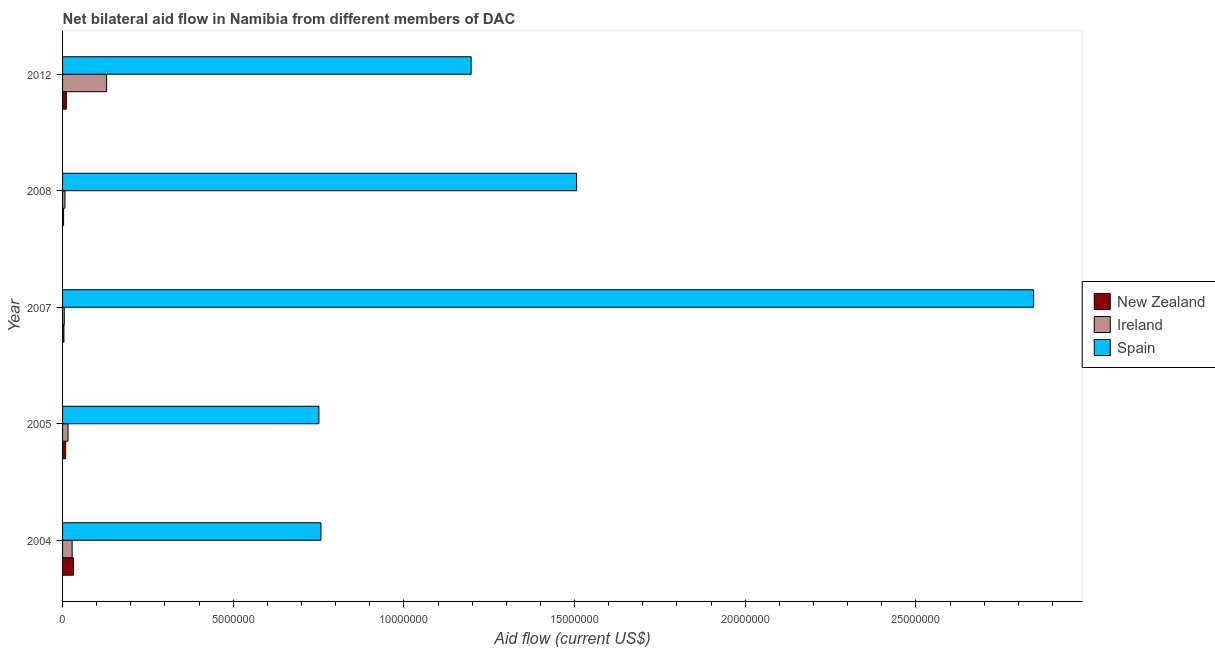How many groups of bars are there?
Provide a short and direct response. 5. Are the number of bars per tick equal to the number of legend labels?
Provide a short and direct response. Yes. Are the number of bars on each tick of the Y-axis equal?
Your answer should be compact. Yes. How many bars are there on the 5th tick from the top?
Your answer should be very brief. 3. How many bars are there on the 3rd tick from the bottom?
Provide a succinct answer. 3. In how many cases, is the number of bars for a given year not equal to the number of legend labels?
Offer a very short reply. 0. What is the amount of aid provided by spain in 2012?
Offer a terse response. 1.20e+07. Across all years, what is the maximum amount of aid provided by new zealand?
Your answer should be compact. 3.20e+05. Across all years, what is the minimum amount of aid provided by spain?
Give a very brief answer. 7.51e+06. In which year was the amount of aid provided by new zealand maximum?
Offer a very short reply. 2004. What is the total amount of aid provided by ireland in the graph?
Your answer should be compact. 1.85e+06. What is the difference between the amount of aid provided by new zealand in 2004 and that in 2008?
Provide a succinct answer. 2.90e+05. What is the difference between the amount of aid provided by spain in 2007 and the amount of aid provided by new zealand in 2008?
Provide a short and direct response. 2.84e+07. What is the average amount of aid provided by new zealand per year?
Offer a very short reply. 1.18e+05. In the year 2008, what is the difference between the amount of aid provided by spain and amount of aid provided by ireland?
Offer a terse response. 1.50e+07. What is the ratio of the amount of aid provided by ireland in 2007 to that in 2008?
Your response must be concise. 0.71. What is the difference between the highest and the second highest amount of aid provided by spain?
Your answer should be compact. 1.34e+07. What is the difference between the highest and the lowest amount of aid provided by new zealand?
Give a very brief answer. 2.90e+05. Is the sum of the amount of aid provided by spain in 2005 and 2007 greater than the maximum amount of aid provided by ireland across all years?
Your response must be concise. Yes. What does the 1st bar from the top in 2008 represents?
Ensure brevity in your answer.  Spain. What does the 2nd bar from the bottom in 2008 represents?
Keep it short and to the point. Ireland. How many bars are there?
Your answer should be compact. 15. Are all the bars in the graph horizontal?
Offer a terse response. Yes. Does the graph contain grids?
Offer a terse response. No. Where does the legend appear in the graph?
Your response must be concise. Center right. What is the title of the graph?
Ensure brevity in your answer.  Net bilateral aid flow in Namibia from different members of DAC. What is the label or title of the Y-axis?
Your answer should be very brief. Year. What is the Aid flow (current US$) of Ireland in 2004?
Your answer should be compact. 2.80e+05. What is the Aid flow (current US$) in Spain in 2004?
Your answer should be compact. 7.57e+06. What is the Aid flow (current US$) in New Zealand in 2005?
Offer a very short reply. 9.00e+04. What is the Aid flow (current US$) in Spain in 2005?
Make the answer very short. 7.51e+06. What is the Aid flow (current US$) in Ireland in 2007?
Give a very brief answer. 5.00e+04. What is the Aid flow (current US$) of Spain in 2007?
Your answer should be compact. 2.84e+07. What is the Aid flow (current US$) of New Zealand in 2008?
Ensure brevity in your answer.  3.00e+04. What is the Aid flow (current US$) in Ireland in 2008?
Provide a succinct answer. 7.00e+04. What is the Aid flow (current US$) in Spain in 2008?
Provide a short and direct response. 1.51e+07. What is the Aid flow (current US$) of Ireland in 2012?
Your answer should be compact. 1.29e+06. What is the Aid flow (current US$) of Spain in 2012?
Give a very brief answer. 1.20e+07. Across all years, what is the maximum Aid flow (current US$) of New Zealand?
Provide a succinct answer. 3.20e+05. Across all years, what is the maximum Aid flow (current US$) in Ireland?
Your answer should be compact. 1.29e+06. Across all years, what is the maximum Aid flow (current US$) of Spain?
Give a very brief answer. 2.84e+07. Across all years, what is the minimum Aid flow (current US$) of New Zealand?
Offer a terse response. 3.00e+04. Across all years, what is the minimum Aid flow (current US$) in Ireland?
Ensure brevity in your answer.  5.00e+04. Across all years, what is the minimum Aid flow (current US$) in Spain?
Your response must be concise. 7.51e+06. What is the total Aid flow (current US$) in New Zealand in the graph?
Offer a terse response. 5.90e+05. What is the total Aid flow (current US$) of Ireland in the graph?
Give a very brief answer. 1.85e+06. What is the total Aid flow (current US$) in Spain in the graph?
Provide a succinct answer. 7.06e+07. What is the difference between the Aid flow (current US$) of New Zealand in 2004 and that in 2005?
Offer a terse response. 2.30e+05. What is the difference between the Aid flow (current US$) in New Zealand in 2004 and that in 2007?
Offer a terse response. 2.80e+05. What is the difference between the Aid flow (current US$) of Ireland in 2004 and that in 2007?
Your response must be concise. 2.30e+05. What is the difference between the Aid flow (current US$) of Spain in 2004 and that in 2007?
Keep it short and to the point. -2.09e+07. What is the difference between the Aid flow (current US$) of Ireland in 2004 and that in 2008?
Offer a very short reply. 2.10e+05. What is the difference between the Aid flow (current US$) of Spain in 2004 and that in 2008?
Ensure brevity in your answer.  -7.49e+06. What is the difference between the Aid flow (current US$) of Ireland in 2004 and that in 2012?
Your response must be concise. -1.01e+06. What is the difference between the Aid flow (current US$) of Spain in 2004 and that in 2012?
Offer a terse response. -4.40e+06. What is the difference between the Aid flow (current US$) in New Zealand in 2005 and that in 2007?
Your response must be concise. 5.00e+04. What is the difference between the Aid flow (current US$) of Spain in 2005 and that in 2007?
Give a very brief answer. -2.09e+07. What is the difference between the Aid flow (current US$) in Spain in 2005 and that in 2008?
Make the answer very short. -7.55e+06. What is the difference between the Aid flow (current US$) of Ireland in 2005 and that in 2012?
Make the answer very short. -1.13e+06. What is the difference between the Aid flow (current US$) in Spain in 2005 and that in 2012?
Offer a very short reply. -4.46e+06. What is the difference between the Aid flow (current US$) of New Zealand in 2007 and that in 2008?
Ensure brevity in your answer.  10000. What is the difference between the Aid flow (current US$) of Spain in 2007 and that in 2008?
Provide a short and direct response. 1.34e+07. What is the difference between the Aid flow (current US$) of New Zealand in 2007 and that in 2012?
Your answer should be compact. -7.00e+04. What is the difference between the Aid flow (current US$) of Ireland in 2007 and that in 2012?
Provide a succinct answer. -1.24e+06. What is the difference between the Aid flow (current US$) in Spain in 2007 and that in 2012?
Your response must be concise. 1.65e+07. What is the difference between the Aid flow (current US$) of New Zealand in 2008 and that in 2012?
Offer a very short reply. -8.00e+04. What is the difference between the Aid flow (current US$) of Ireland in 2008 and that in 2012?
Give a very brief answer. -1.22e+06. What is the difference between the Aid flow (current US$) in Spain in 2008 and that in 2012?
Provide a succinct answer. 3.09e+06. What is the difference between the Aid flow (current US$) of New Zealand in 2004 and the Aid flow (current US$) of Spain in 2005?
Offer a terse response. -7.19e+06. What is the difference between the Aid flow (current US$) of Ireland in 2004 and the Aid flow (current US$) of Spain in 2005?
Your response must be concise. -7.23e+06. What is the difference between the Aid flow (current US$) in New Zealand in 2004 and the Aid flow (current US$) in Spain in 2007?
Make the answer very short. -2.81e+07. What is the difference between the Aid flow (current US$) in Ireland in 2004 and the Aid flow (current US$) in Spain in 2007?
Your response must be concise. -2.82e+07. What is the difference between the Aid flow (current US$) in New Zealand in 2004 and the Aid flow (current US$) in Spain in 2008?
Keep it short and to the point. -1.47e+07. What is the difference between the Aid flow (current US$) in Ireland in 2004 and the Aid flow (current US$) in Spain in 2008?
Your response must be concise. -1.48e+07. What is the difference between the Aid flow (current US$) of New Zealand in 2004 and the Aid flow (current US$) of Ireland in 2012?
Offer a terse response. -9.70e+05. What is the difference between the Aid flow (current US$) of New Zealand in 2004 and the Aid flow (current US$) of Spain in 2012?
Your answer should be very brief. -1.16e+07. What is the difference between the Aid flow (current US$) of Ireland in 2004 and the Aid flow (current US$) of Spain in 2012?
Keep it short and to the point. -1.17e+07. What is the difference between the Aid flow (current US$) in New Zealand in 2005 and the Aid flow (current US$) in Ireland in 2007?
Ensure brevity in your answer.  4.00e+04. What is the difference between the Aid flow (current US$) in New Zealand in 2005 and the Aid flow (current US$) in Spain in 2007?
Give a very brief answer. -2.84e+07. What is the difference between the Aid flow (current US$) in Ireland in 2005 and the Aid flow (current US$) in Spain in 2007?
Give a very brief answer. -2.83e+07. What is the difference between the Aid flow (current US$) in New Zealand in 2005 and the Aid flow (current US$) in Ireland in 2008?
Offer a very short reply. 2.00e+04. What is the difference between the Aid flow (current US$) in New Zealand in 2005 and the Aid flow (current US$) in Spain in 2008?
Provide a short and direct response. -1.50e+07. What is the difference between the Aid flow (current US$) of Ireland in 2005 and the Aid flow (current US$) of Spain in 2008?
Keep it short and to the point. -1.49e+07. What is the difference between the Aid flow (current US$) in New Zealand in 2005 and the Aid flow (current US$) in Ireland in 2012?
Give a very brief answer. -1.20e+06. What is the difference between the Aid flow (current US$) of New Zealand in 2005 and the Aid flow (current US$) of Spain in 2012?
Your response must be concise. -1.19e+07. What is the difference between the Aid flow (current US$) of Ireland in 2005 and the Aid flow (current US$) of Spain in 2012?
Keep it short and to the point. -1.18e+07. What is the difference between the Aid flow (current US$) in New Zealand in 2007 and the Aid flow (current US$) in Spain in 2008?
Offer a terse response. -1.50e+07. What is the difference between the Aid flow (current US$) of Ireland in 2007 and the Aid flow (current US$) of Spain in 2008?
Ensure brevity in your answer.  -1.50e+07. What is the difference between the Aid flow (current US$) in New Zealand in 2007 and the Aid flow (current US$) in Ireland in 2012?
Provide a short and direct response. -1.25e+06. What is the difference between the Aid flow (current US$) of New Zealand in 2007 and the Aid flow (current US$) of Spain in 2012?
Give a very brief answer. -1.19e+07. What is the difference between the Aid flow (current US$) of Ireland in 2007 and the Aid flow (current US$) of Spain in 2012?
Your answer should be compact. -1.19e+07. What is the difference between the Aid flow (current US$) in New Zealand in 2008 and the Aid flow (current US$) in Ireland in 2012?
Keep it short and to the point. -1.26e+06. What is the difference between the Aid flow (current US$) in New Zealand in 2008 and the Aid flow (current US$) in Spain in 2012?
Your answer should be very brief. -1.19e+07. What is the difference between the Aid flow (current US$) of Ireland in 2008 and the Aid flow (current US$) of Spain in 2012?
Keep it short and to the point. -1.19e+07. What is the average Aid flow (current US$) in New Zealand per year?
Your response must be concise. 1.18e+05. What is the average Aid flow (current US$) of Spain per year?
Your response must be concise. 1.41e+07. In the year 2004, what is the difference between the Aid flow (current US$) in New Zealand and Aid flow (current US$) in Spain?
Your answer should be compact. -7.25e+06. In the year 2004, what is the difference between the Aid flow (current US$) in Ireland and Aid flow (current US$) in Spain?
Your response must be concise. -7.29e+06. In the year 2005, what is the difference between the Aid flow (current US$) of New Zealand and Aid flow (current US$) of Spain?
Your answer should be compact. -7.42e+06. In the year 2005, what is the difference between the Aid flow (current US$) in Ireland and Aid flow (current US$) in Spain?
Provide a short and direct response. -7.35e+06. In the year 2007, what is the difference between the Aid flow (current US$) of New Zealand and Aid flow (current US$) of Ireland?
Provide a succinct answer. -10000. In the year 2007, what is the difference between the Aid flow (current US$) of New Zealand and Aid flow (current US$) of Spain?
Offer a terse response. -2.84e+07. In the year 2007, what is the difference between the Aid flow (current US$) of Ireland and Aid flow (current US$) of Spain?
Provide a succinct answer. -2.84e+07. In the year 2008, what is the difference between the Aid flow (current US$) of New Zealand and Aid flow (current US$) of Spain?
Your response must be concise. -1.50e+07. In the year 2008, what is the difference between the Aid flow (current US$) in Ireland and Aid flow (current US$) in Spain?
Offer a terse response. -1.50e+07. In the year 2012, what is the difference between the Aid flow (current US$) in New Zealand and Aid flow (current US$) in Ireland?
Your response must be concise. -1.18e+06. In the year 2012, what is the difference between the Aid flow (current US$) in New Zealand and Aid flow (current US$) in Spain?
Offer a very short reply. -1.19e+07. In the year 2012, what is the difference between the Aid flow (current US$) of Ireland and Aid flow (current US$) of Spain?
Provide a succinct answer. -1.07e+07. What is the ratio of the Aid flow (current US$) in New Zealand in 2004 to that in 2005?
Ensure brevity in your answer.  3.56. What is the ratio of the Aid flow (current US$) in Spain in 2004 to that in 2005?
Your answer should be very brief. 1.01. What is the ratio of the Aid flow (current US$) of Ireland in 2004 to that in 2007?
Give a very brief answer. 5.6. What is the ratio of the Aid flow (current US$) of Spain in 2004 to that in 2007?
Provide a succinct answer. 0.27. What is the ratio of the Aid flow (current US$) of New Zealand in 2004 to that in 2008?
Give a very brief answer. 10.67. What is the ratio of the Aid flow (current US$) in Ireland in 2004 to that in 2008?
Your answer should be very brief. 4. What is the ratio of the Aid flow (current US$) in Spain in 2004 to that in 2008?
Your answer should be very brief. 0.5. What is the ratio of the Aid flow (current US$) of New Zealand in 2004 to that in 2012?
Offer a very short reply. 2.91. What is the ratio of the Aid flow (current US$) in Ireland in 2004 to that in 2012?
Give a very brief answer. 0.22. What is the ratio of the Aid flow (current US$) of Spain in 2004 to that in 2012?
Offer a terse response. 0.63. What is the ratio of the Aid flow (current US$) in New Zealand in 2005 to that in 2007?
Your response must be concise. 2.25. What is the ratio of the Aid flow (current US$) in Ireland in 2005 to that in 2007?
Make the answer very short. 3.2. What is the ratio of the Aid flow (current US$) in Spain in 2005 to that in 2007?
Provide a short and direct response. 0.26. What is the ratio of the Aid flow (current US$) in New Zealand in 2005 to that in 2008?
Your answer should be very brief. 3. What is the ratio of the Aid flow (current US$) of Ireland in 2005 to that in 2008?
Offer a terse response. 2.29. What is the ratio of the Aid flow (current US$) of Spain in 2005 to that in 2008?
Your response must be concise. 0.5. What is the ratio of the Aid flow (current US$) of New Zealand in 2005 to that in 2012?
Ensure brevity in your answer.  0.82. What is the ratio of the Aid flow (current US$) in Ireland in 2005 to that in 2012?
Your answer should be compact. 0.12. What is the ratio of the Aid flow (current US$) of Spain in 2005 to that in 2012?
Offer a terse response. 0.63. What is the ratio of the Aid flow (current US$) in Ireland in 2007 to that in 2008?
Your answer should be very brief. 0.71. What is the ratio of the Aid flow (current US$) of Spain in 2007 to that in 2008?
Make the answer very short. 1.89. What is the ratio of the Aid flow (current US$) of New Zealand in 2007 to that in 2012?
Give a very brief answer. 0.36. What is the ratio of the Aid flow (current US$) in Ireland in 2007 to that in 2012?
Give a very brief answer. 0.04. What is the ratio of the Aid flow (current US$) in Spain in 2007 to that in 2012?
Make the answer very short. 2.38. What is the ratio of the Aid flow (current US$) of New Zealand in 2008 to that in 2012?
Provide a short and direct response. 0.27. What is the ratio of the Aid flow (current US$) in Ireland in 2008 to that in 2012?
Keep it short and to the point. 0.05. What is the ratio of the Aid flow (current US$) of Spain in 2008 to that in 2012?
Offer a terse response. 1.26. What is the difference between the highest and the second highest Aid flow (current US$) in New Zealand?
Your answer should be very brief. 2.10e+05. What is the difference between the highest and the second highest Aid flow (current US$) in Ireland?
Make the answer very short. 1.01e+06. What is the difference between the highest and the second highest Aid flow (current US$) in Spain?
Ensure brevity in your answer.  1.34e+07. What is the difference between the highest and the lowest Aid flow (current US$) of New Zealand?
Offer a very short reply. 2.90e+05. What is the difference between the highest and the lowest Aid flow (current US$) of Ireland?
Make the answer very short. 1.24e+06. What is the difference between the highest and the lowest Aid flow (current US$) in Spain?
Give a very brief answer. 2.09e+07. 